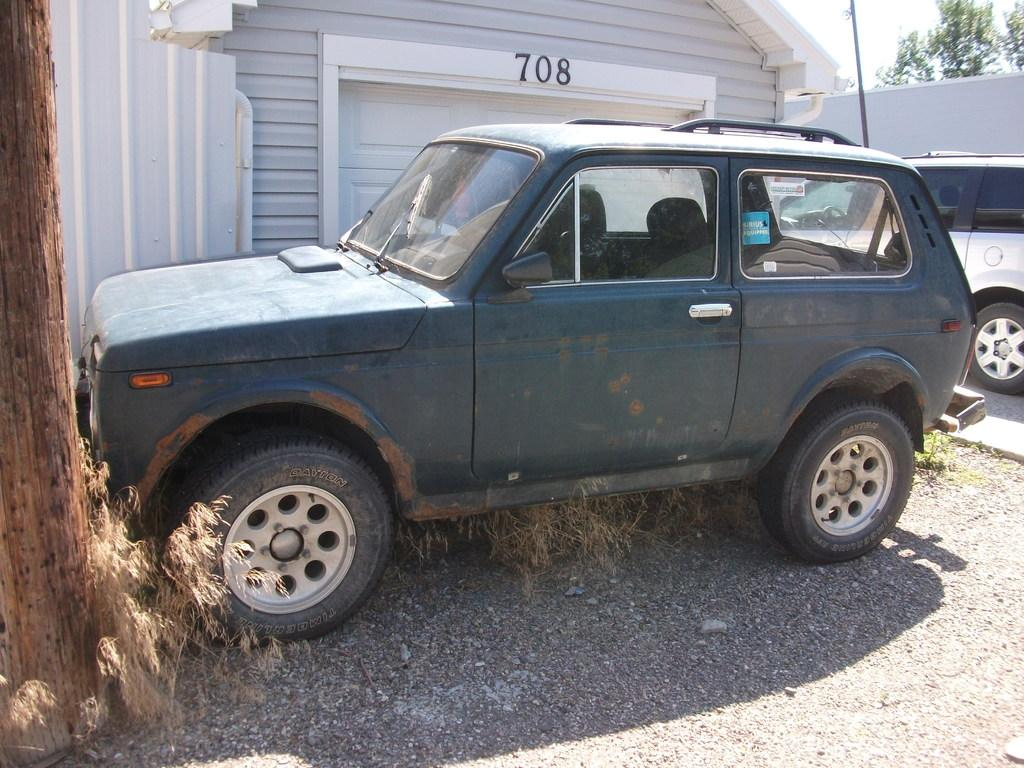<image>
Write a terse but informative summary of the picture. A rusted SUV is parked in front of a garage with the address number of 708 